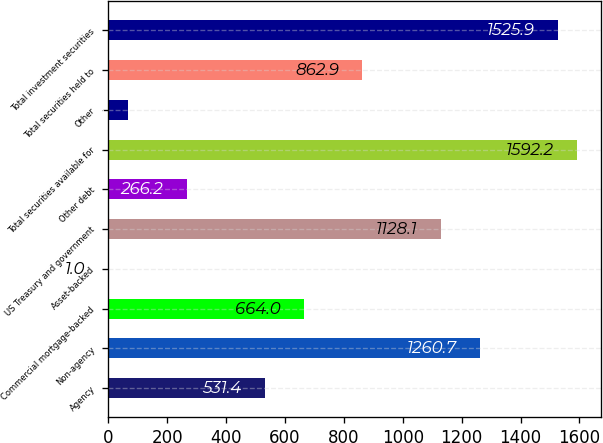Convert chart to OTSL. <chart><loc_0><loc_0><loc_500><loc_500><bar_chart><fcel>Agency<fcel>Non-agency<fcel>Commercial mortgage-backed<fcel>Asset-backed<fcel>US Treasury and government<fcel>Other debt<fcel>Total securities available for<fcel>Other<fcel>Total securities held to<fcel>Total investment securities<nl><fcel>531.4<fcel>1260.7<fcel>664<fcel>1<fcel>1128.1<fcel>266.2<fcel>1592.2<fcel>67.3<fcel>862.9<fcel>1525.9<nl></chart> 